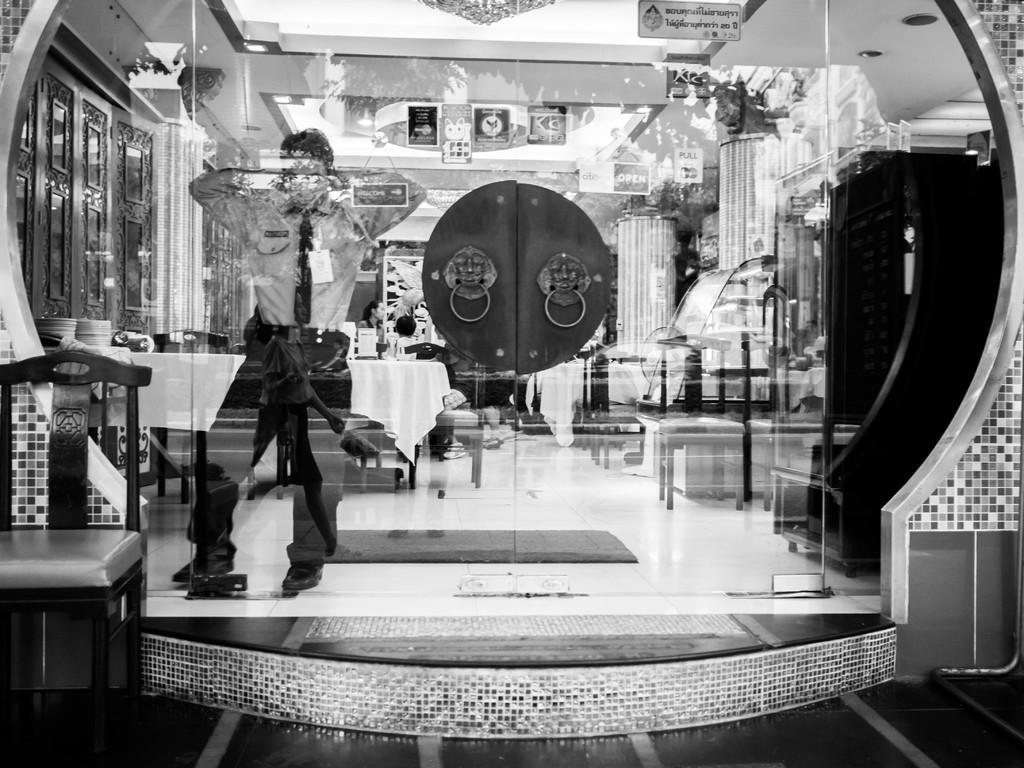Please provide a concise description of this image. On the left side of the image there is a chair. There is a glass door through which we can see a person standing on the floor. There are people sitting on the chairs. There are tables. On top of it there are a few objects. There are boards and some other objects. There is a mat on the floor. On top of the image there are lights. 